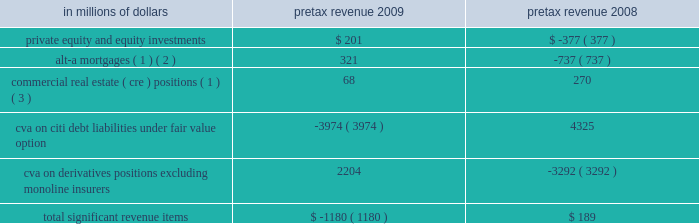2009 vs .
2008 revenues , net of interest expense increased 11% ( 11 % ) or $ 2.7 billion , as markets began to recover in the early part of 2009 , bringing back higher levels of volume activity and higher levels of liquidity , which began to decline again in the third quarter of 2009 .
The growth in revenue in the early part of the year was mainly due to a $ 7.1 billion increase in fixed income markets , reflecting strong trading opportunities across all asset classes in the first half of 2009 , and a $ 1.5 billion increase in investment banking revenue primarily from increases in debt and equity underwriting activities reflecting higher transaction volumes from depressed 2008 levels .
These increases were offset by a $ 6.4 billion decrease in lending revenue primarily from losses on credit default swap hedges .
Excluding the 2009 and 2008 cva impact , as indicated in the table below , revenues increased 23% ( 23 % ) or $ 5.5 billion .
Operating expenses decreased 17% ( 17 % ) , or $ 2.7 billion .
Excluding the 2008 repositioning and restructuring charges and the 2009 litigation reserve release , operating expenses declined 11% ( 11 % ) or $ 1.6 billion , mainly as a result of headcount reductions and benefits from expense management .
Provisions for loan losses and for benefits and claims decreased 7% ( 7 % ) or $ 129 million , to $ 1.7 billion , mainly due to lower credit reserve builds and net credit losses , due to an improved credit environment , particularly in the latter part of the year .
2008 vs .
2007 revenues , net of interest expense decreased 2% ( 2 % ) or $ 0.4 billion reflecting the overall difficult market conditions .
Excluding the 2008 and 2007 cva impact , revenues decreased 3% ( 3 % ) or $ 0.6 billion .
The reduction in revenue was primarily due to a decrease in investment banking revenue of $ 2.3 billion to $ 3.2 billion , mainly in debt and equity underwriting , reflecting lower volumes , and a decrease in equity markets revenue of $ 2.3 billion to $ 2.9 billion due to extremely high volatility and reduced levels of activity .
These reductions were offset by an increase in fixed income markets of $ 2.9 billion to $ 14.4 billion due to strong performance in interest rates and currencies , and an increase in lending revenue of $ 2.4 billion to $ 4.2 billion mainly from gains on credit default swap hedges .
Operating expenses decreased by 2% ( 2 % ) or $ 0.4 billion .
Excluding the 2008 and 2007 repositioning and restructuring charges and the 2007 litigation reserve reversal , operating expenses decreased by 7% ( 7 % ) or $ 1.1 billion driven by headcount reduction and lower performance-based incentives .
Provisions for credit losses and for benefits and claims increased $ 1.3 billion to $ 1.8 billion mainly from higher credit reserve builds and net credit losses offset by a lower provision for unfunded lending commitments due to deterioration in the credit environment .
Certain revenues impacting securities and banking items that impacted s&b revenues during 2009 and 2008 are set forth in the table below. .
( 1 ) net of hedges .
( 2 ) for these purposes , alt-a mortgage securities are non-agency residential mortgage-backed securities ( rmbs ) where ( i ) the underlying collateral has weighted average fico scores between 680 and 720 or ( ii ) for instances where fico scores are greater than 720 , rmbs have 30% ( 30 % ) or less of the underlying collateral composed of full documentation loans .
See 201cmanaging global risk 2014credit risk 2014u.s .
Consumer mortgage lending . 201d ( 3 ) s&b 2019s commercial real estate exposure is split into three categories of assets : held at fair value ; held- to-maturity/held-for-investment ; and equity .
See 201cmanaging global risk 2014credit risk 2014exposure to commercial real estate 201d section for a further discussion .
In the table above , 2009 includes a $ 330 million pretax adjustment to the cva balance , which reduced pretax revenues for the year , reflecting a correction of an error related to prior periods .
See 201csignificant accounting policies and significant estimates 201d below and notes 1 and 34 to the consolidated financial statements for a further discussion of this adjustment .
2010 outlook the 2010 outlook for s&b will depend on the level of client activity and on macroeconomic conditions , market valuations and volatility , interest rates and other market factors .
Management of s&b currently expects to maintain client activity throughout 2010 and to operate in market conditions that offer moderate volatility and increased liquidity .
Operating expenses will benefit from continued re-engineering and expense management initiatives , but will be offset by investments in talent and infrastructure to support growth. .
What was the revenues , net of interest expense in billions in 2008 reflecting the overall difficult market conditions .? 
Computations: ((0.4 / 2%) - 0.4)
Answer: 19.6. 